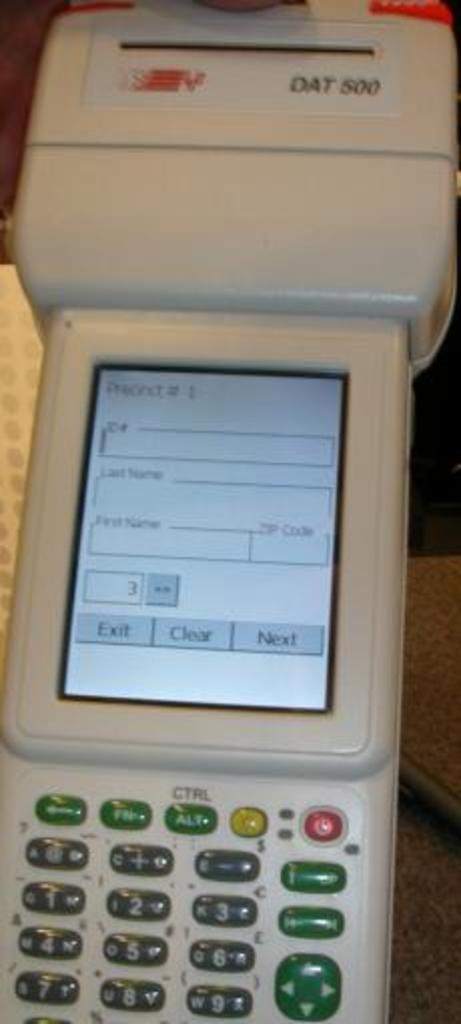<image>
Render a clear and concise summary of the photo. Dat 500 that is used to fill out important details on customers. 